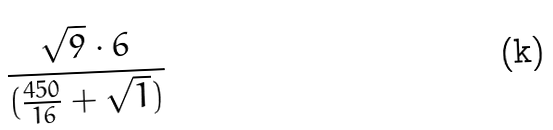Convert formula to latex. <formula><loc_0><loc_0><loc_500><loc_500>\frac { \sqrt { 9 } \cdot 6 } { ( \frac { 4 5 0 } { 1 6 } + \sqrt { 1 } ) }</formula> 